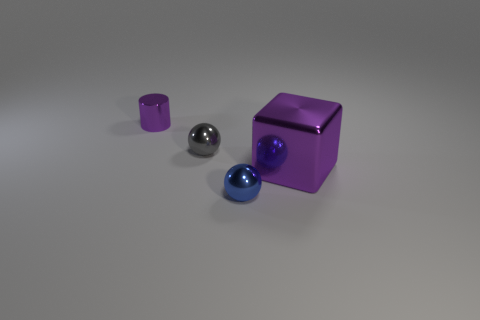Add 1 big cyan rubber objects. How many objects exist? 5 Subtract all cylinders. How many objects are left? 3 Add 3 blue things. How many blue things are left? 4 Add 4 big cyan metallic objects. How many big cyan metallic objects exist? 4 Subtract 0 blue cubes. How many objects are left? 4 Subtract all large yellow metal things. Subtract all big purple objects. How many objects are left? 3 